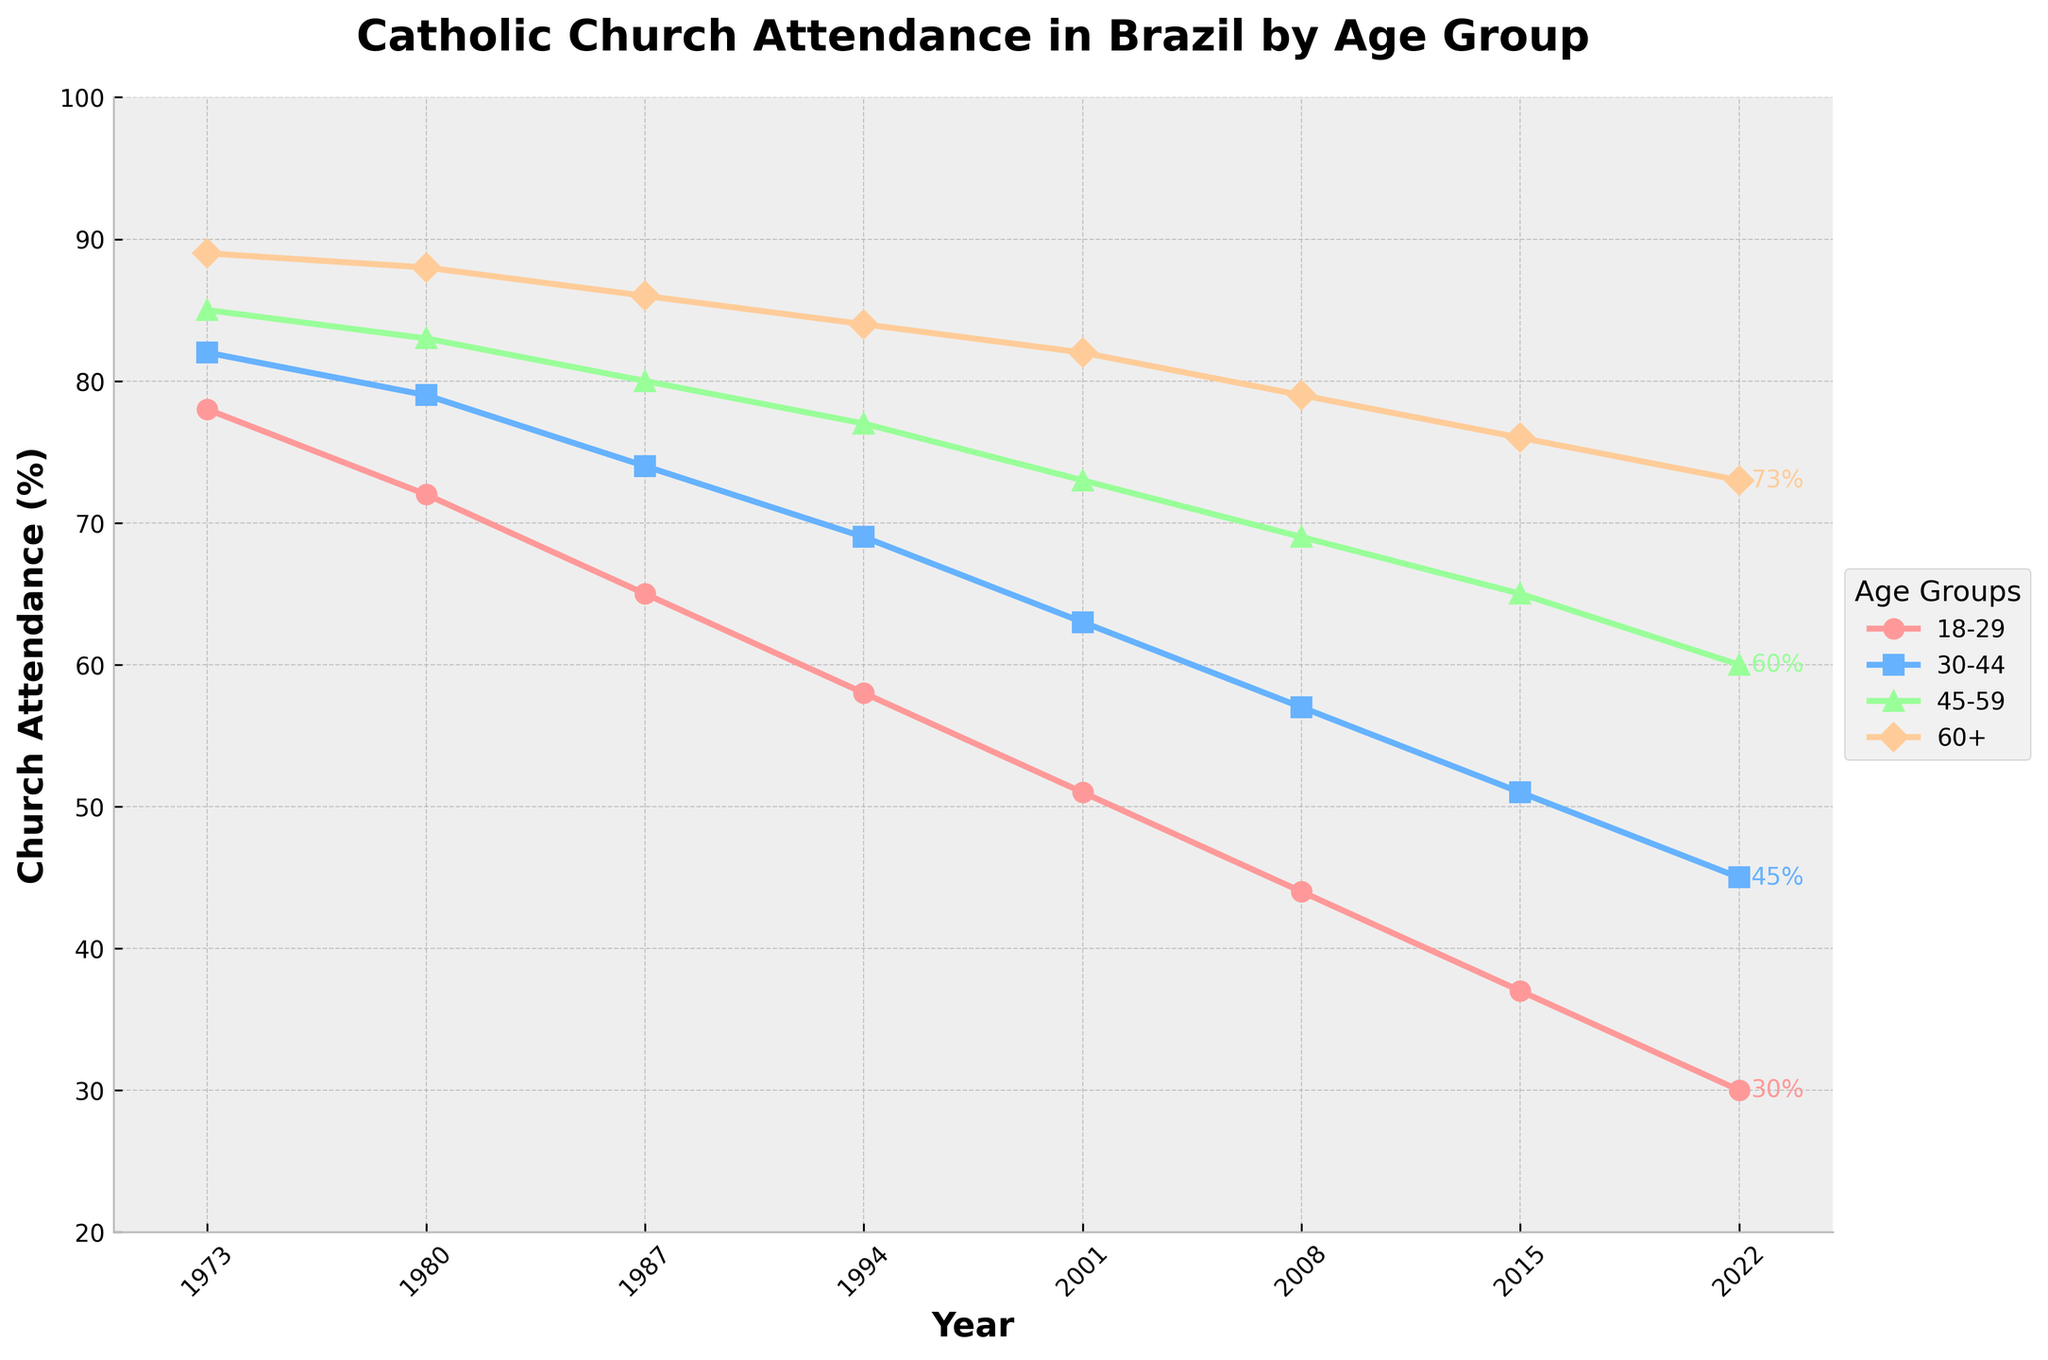What is the trend of church attendance for the 18-29 age group from 1973 to 2022? The trend shows that church attendance for the 18-29 age group has steadily decreased from 78% in 1973 to 30% in 2022.
Answer: Decreasing Which age group had the highest church attendance in 2022? By looking at the endpoint of the lines in the 2022 column, the 60+ age group had the highest church attendance at 73%.
Answer: 60+ How much did church attendance for the 30-44 age group drop between 1973 and 2022? The attendance dropped from 82% in 1973 to 45% in 2022. The difference is 82 - 45 = 37.
Answer: 37% Which age group saw the steepest decline in church attendance over the 50-year period? Comparing the slopes of the lines for each age group, the 18-29 age group has the steepest decline, from 78% in 1973 to 30% in 2022.
Answer: 18-29 What is the average church attendance for the 45-59 age group over the entire period? The average is calculated by summing the values and dividing by the number of years: (85+83+80+77+73+69+65+60) / 8 = 74
Answer: 74% Did any age group maintain or increase its church attendance over time? None of the age groups maintained or increased their church attendance; all have shown a decrease from 1973 to 2022.
Answer: No Which age group had the smallest decline in church attendance from 1973 to 2022? The 60+ age group had the smallest decline, going from 89% in 1973 to 73% in 2022, a decrease of 16%.
Answer: 60+ In which year did the 18-29 age group experience the largest drop in church attendance? The largest drop occurred between 1973 and 1980, where the attendance fell from 78% to 72%, a 6% drop.
Answer: 1973-1980 How does the attendance for the 45-59 age group in 2001 compare to the attendance for the 18-29 age group in the same year? In 2001, the 45-59 age group had an attendance of 73%, while the 18-29 age group had an attendance of 51%. 73% is greater than 51%.
Answer: Higher What was the overall trend in church attendance for all age groups from 1973 to 2022? The overall trend for all age groups shows a decline in church attendance over the 50-year period.
Answer: Decreasing 